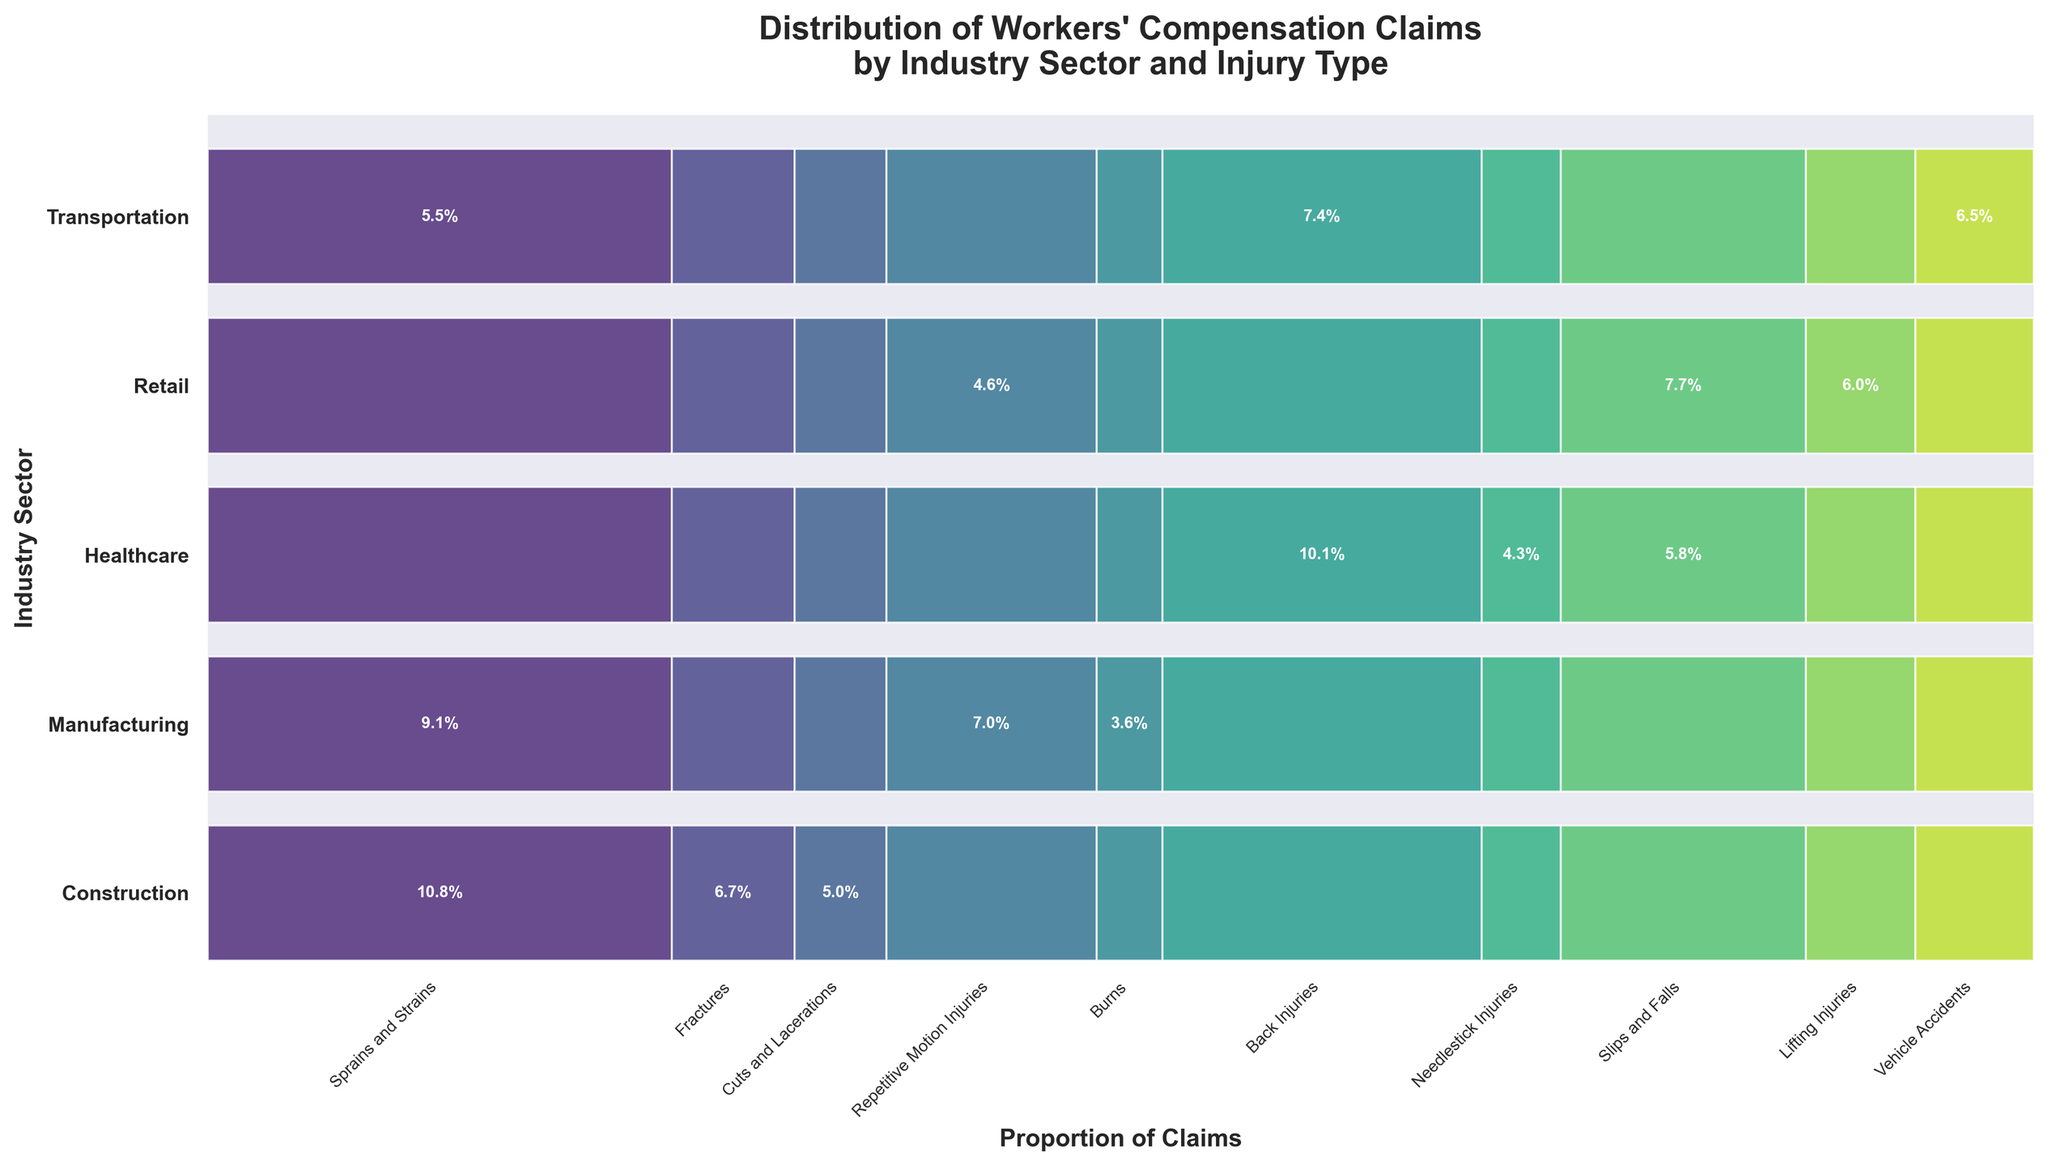What's the title of the plot? The title is typically found at the top of the figure. In this case, it reads "Distribution of Workers' Compensation Claims by Industry Sector and Injury Type".
Answer: Distribution of Workers' Compensation Claims by Industry Sector and Injury Type How are the industries labeled on the y-axis? The labels on the y-axis are the names of the industries involved, listed vertically. These labels are "Construction", "Manufacturing", "Healthcare", "Retail", and "Transportation".
Answer: Construction, Manufacturing, Healthcare, Retail, Transportation Which injury type has the highest proportion of claims in the healthcare industry? By looking at the mosaic plot, observe the segment for "Healthcare" and identify the largest block. The largest block for healthcare corresponds to "Back Injuries".
Answer: Back Injuries Which industry has the smallest proportion of "Repetitive Motion Injuries" claims? By examining the mosaic plot and looking at the "Repetitive Motion Injuries" segments across all industries, note that the transportation sector has a very small segment for this injury type.
Answer: Transportation How does the proportion of "Sprains and Strains" claims in construction compare to manufacturing? Compare the segments of "Sprains and Strains" in the construction and manufacturing rows. The construction sector segment is larger, indicating a higher proportion of these claims.
Answer: Higher in Construction What are the two injury types most associated with construction? By observing the largest segments in the construction row, the two prominent blocks are for "Sprains and Strains" and "Fractures".
Answer: Sprains and Strains, Fractures Which industry shows a significant proportion of "Slips and Falls" claims? Identify the large segments corresponding to "Slips and Falls". Both "Healthcare" and "Retail" show significant proportions, but the "Retail" industry has the more noticeable segment.
Answer: Retail What is the approximate proportion of "Vehicle Accidents" claims in the transportation industry? Find the "Vehicle Accidents" segment in the transportation row and read the label inside the bar. It indicates the proportion to be around 27%.
Answer: 27% Which injury type is exclusive or most prominent in healthcare and not present in other industries? By analyzing each injury type across different industries, "Needlestick Injuries" is only prominent in healthcare and not seen elsewhere.
Answer: Needlestick Injuries Between construction and healthcare, which has a higher proportion of total claims for "Sprains and Strains"? Compare the segments in the rows labeled "Construction" and "Healthcare" for "Sprains and Strains". The construction segment is larger, indicating a higher proportion for these claims.
Answer: Construction 